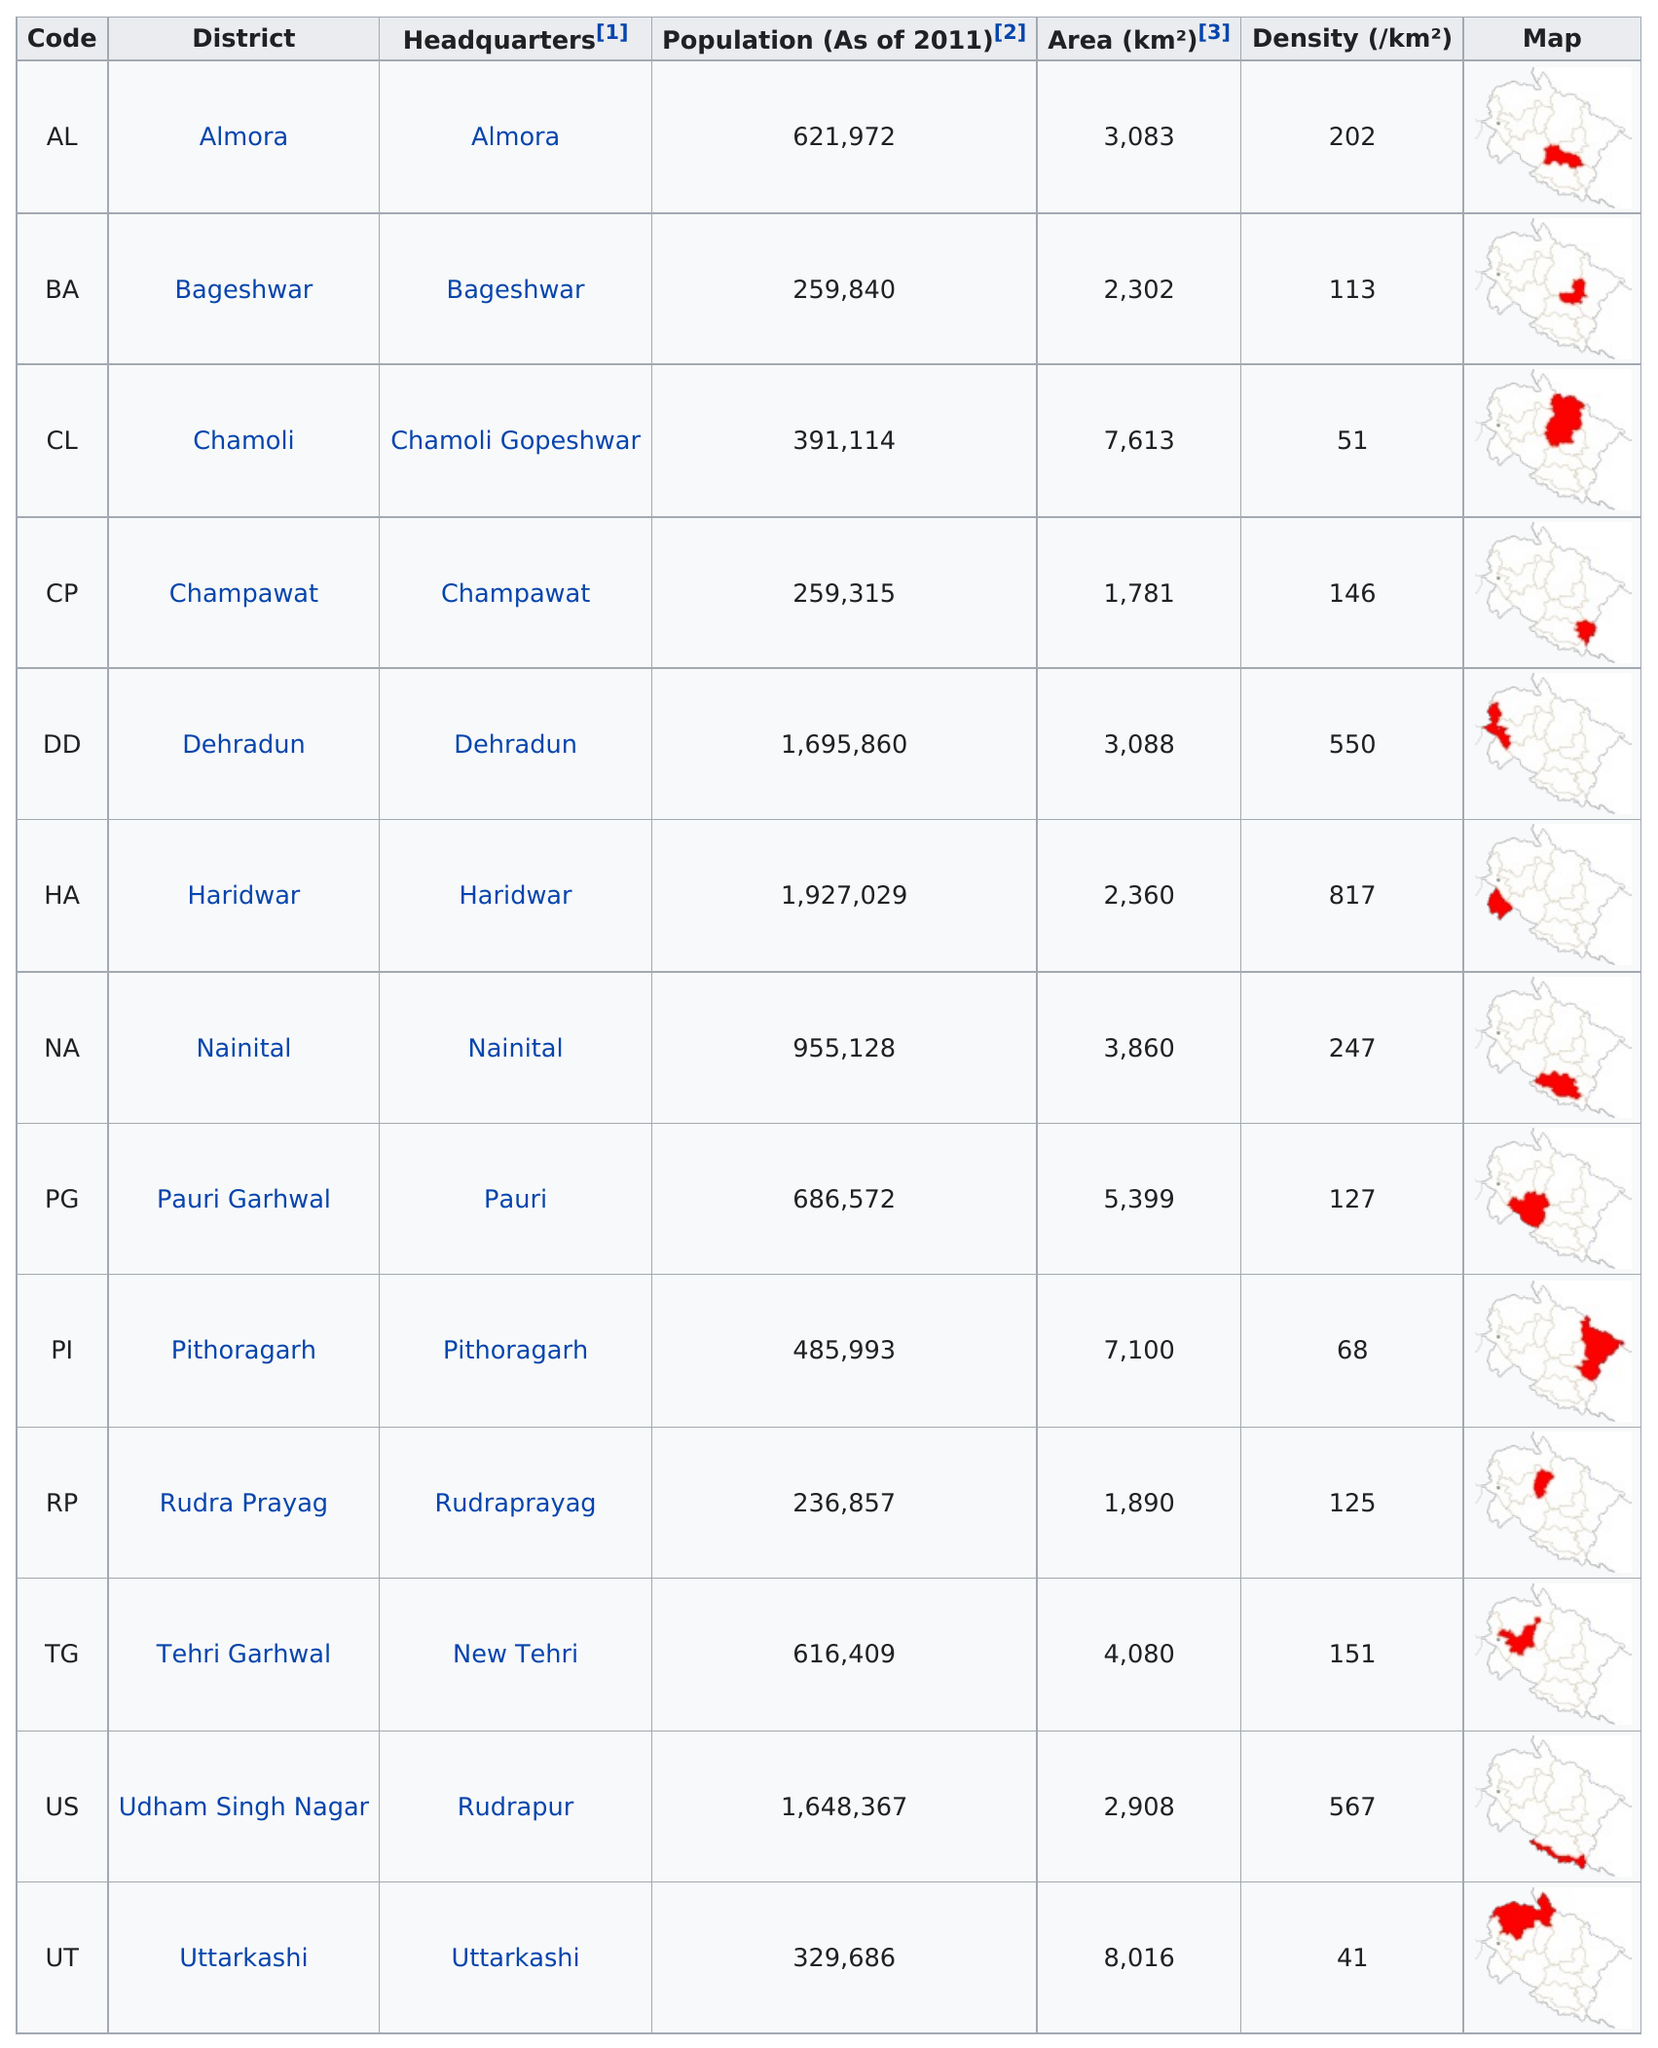Specify some key components in this picture. There are a total of 13 districts in this area. Dehradun has a larger population than Nainital. Chamoli district has a population density of only 51, In the Udham Singh Nagar district, there are approximately 16,483,670 people. If a person were headquartered in Almora, then their district would be Almora. 